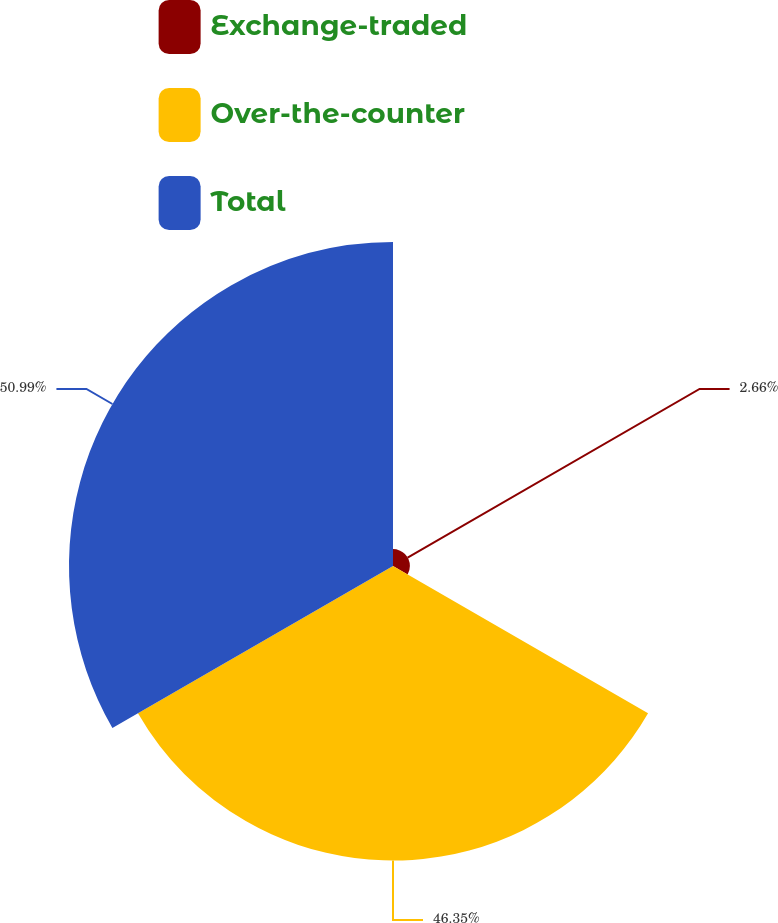Convert chart. <chart><loc_0><loc_0><loc_500><loc_500><pie_chart><fcel>Exchange-traded<fcel>Over-the-counter<fcel>Total<nl><fcel>2.66%<fcel>46.35%<fcel>50.99%<nl></chart> 